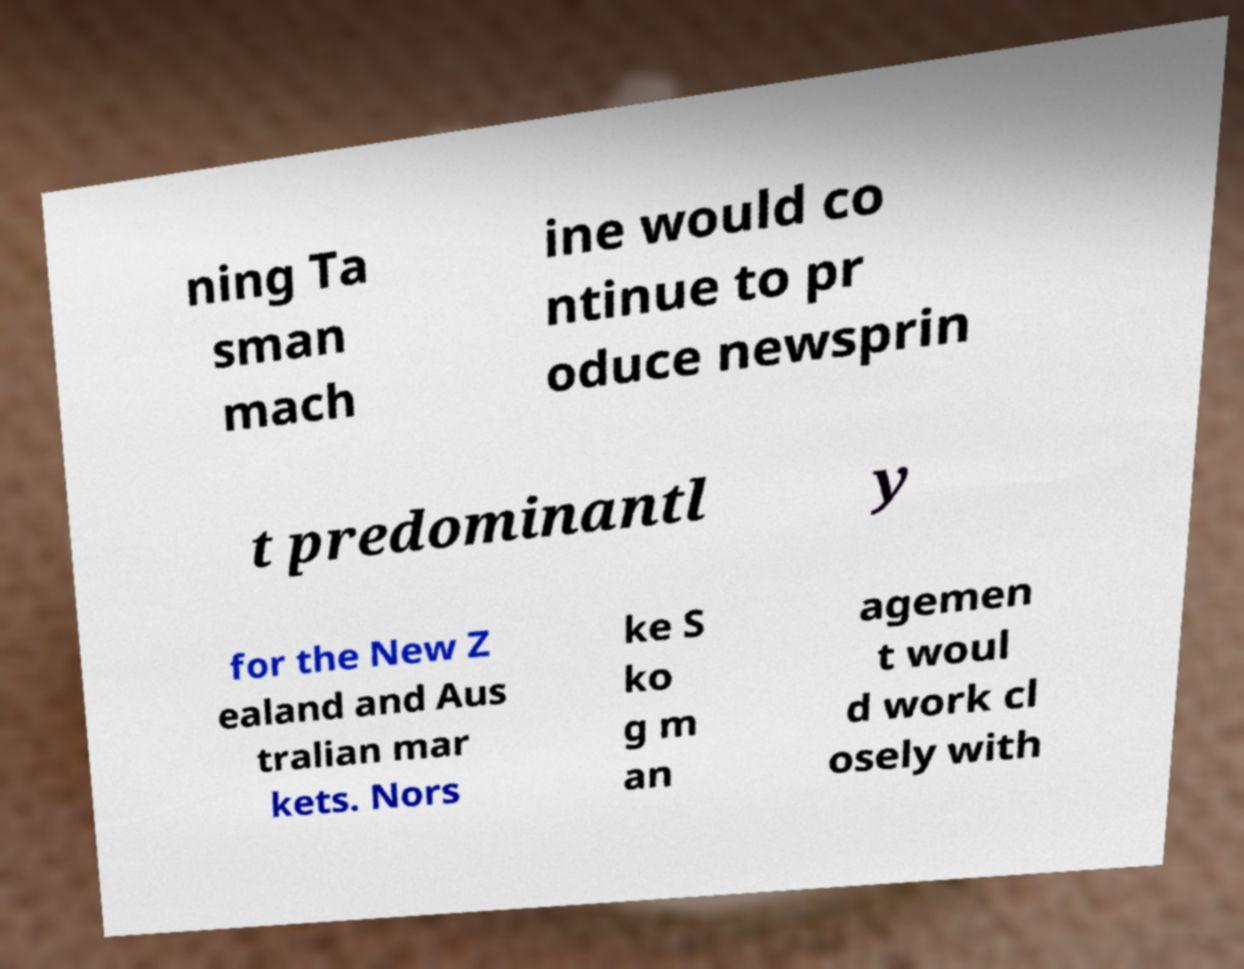Please read and relay the text visible in this image. What does it say? ning Ta sman mach ine would co ntinue to pr oduce newsprin t predominantl y for the New Z ealand and Aus tralian mar kets. Nors ke S ko g m an agemen t woul d work cl osely with 